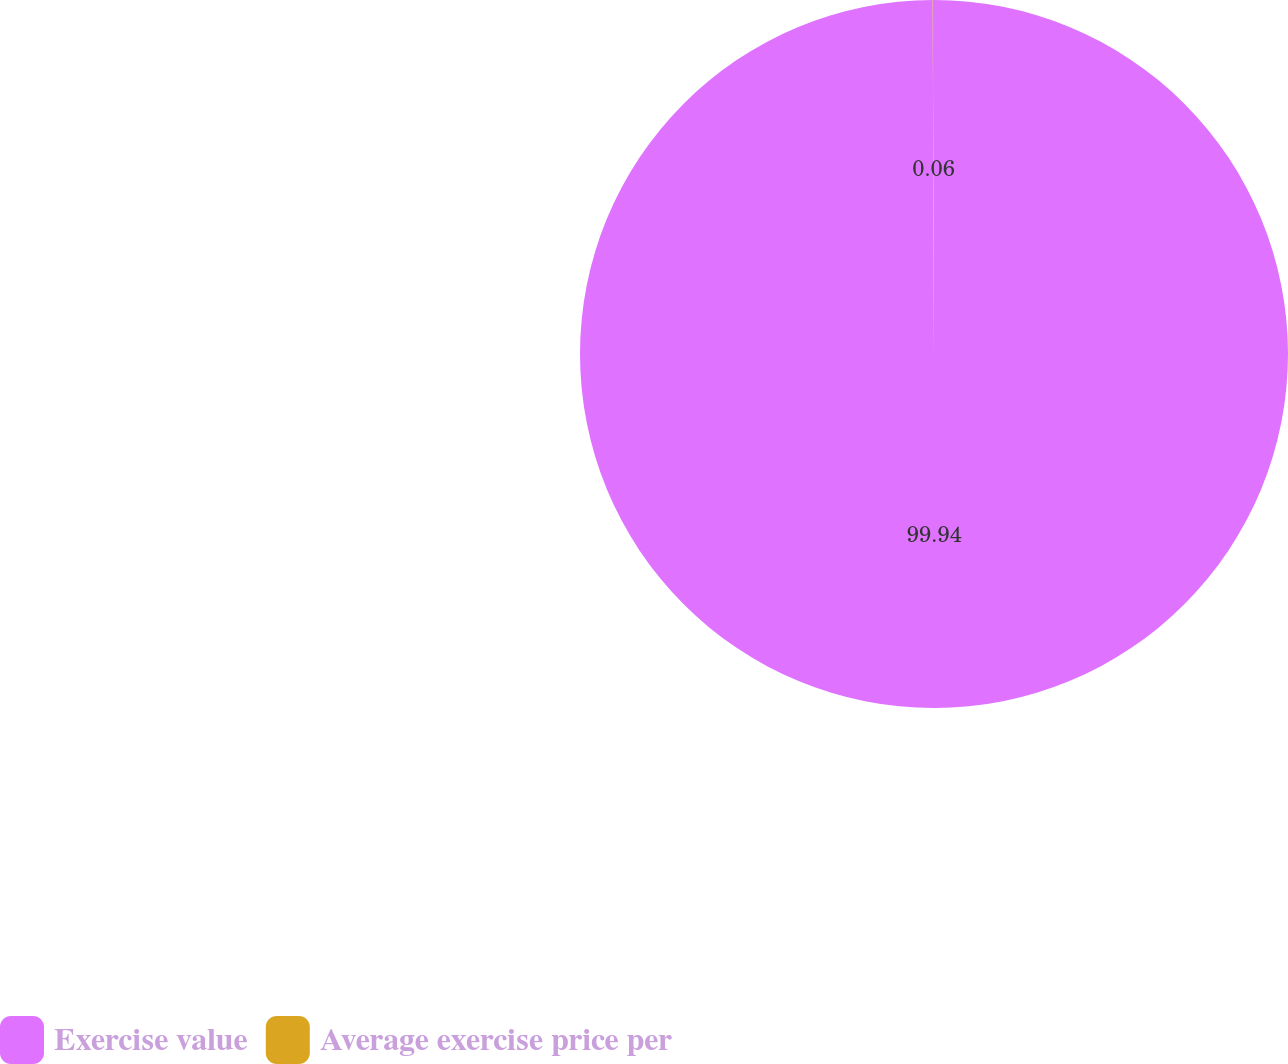Convert chart to OTSL. <chart><loc_0><loc_0><loc_500><loc_500><pie_chart><fcel>Exercise value<fcel>Average exercise price per<nl><fcel>99.94%<fcel>0.06%<nl></chart> 